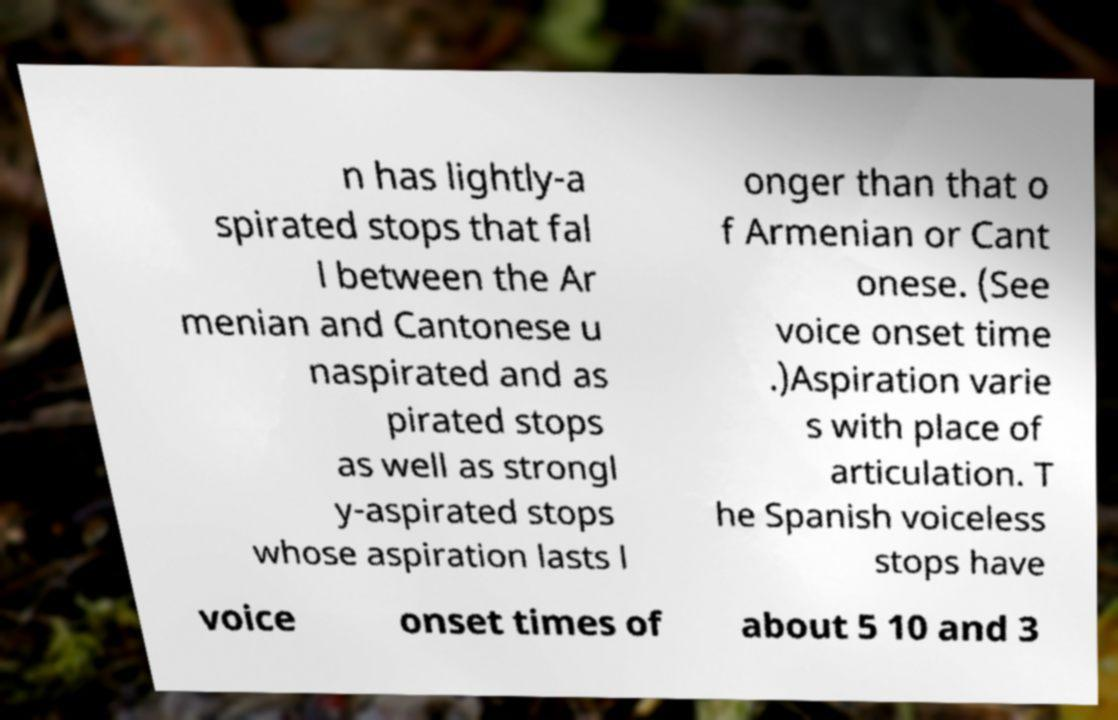For documentation purposes, I need the text within this image transcribed. Could you provide that? n has lightly-a spirated stops that fal l between the Ar menian and Cantonese u naspirated and as pirated stops as well as strongl y-aspirated stops whose aspiration lasts l onger than that o f Armenian or Cant onese. (See voice onset time .)Aspiration varie s with place of articulation. T he Spanish voiceless stops have voice onset times of about 5 10 and 3 